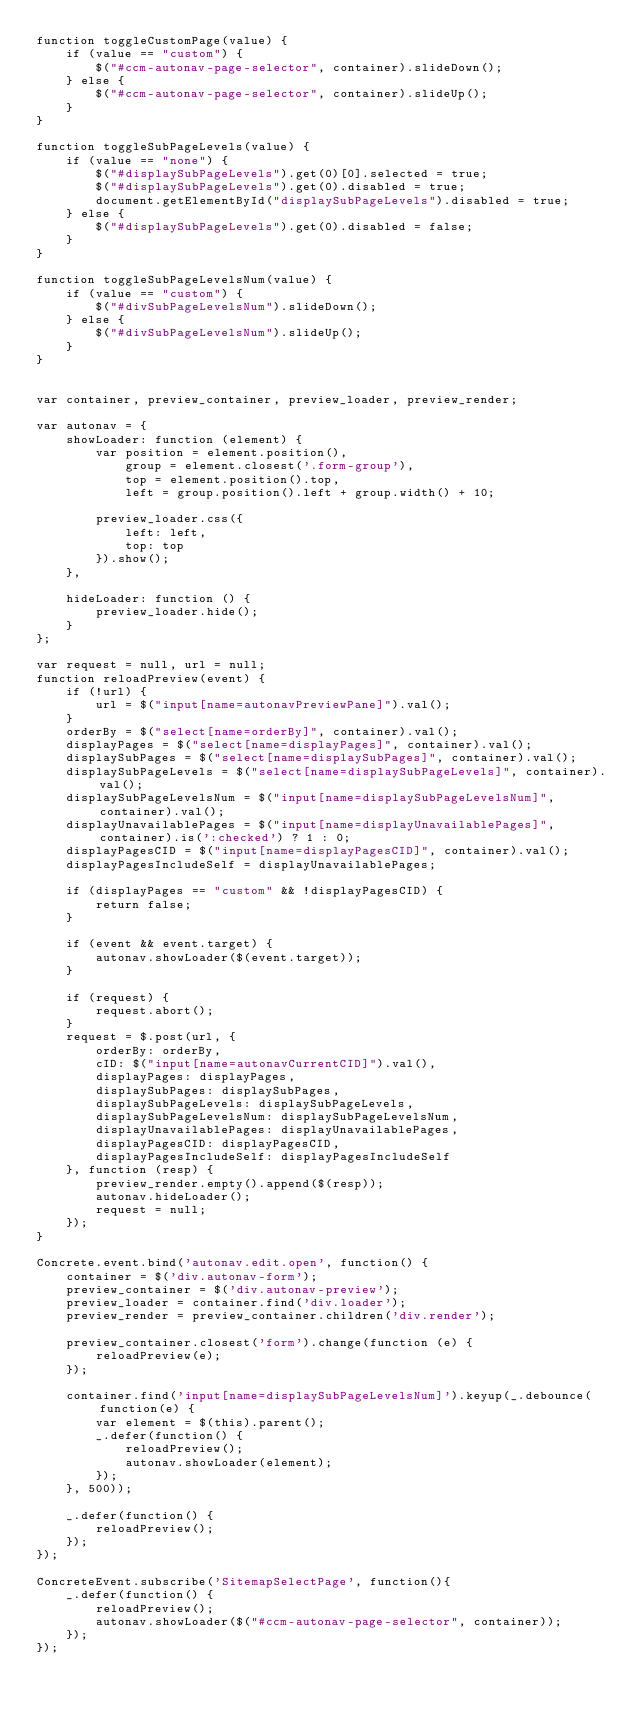<code> <loc_0><loc_0><loc_500><loc_500><_JavaScript_>function toggleCustomPage(value) {
    if (value == "custom") {
        $("#ccm-autonav-page-selector", container).slideDown();
    } else {
        $("#ccm-autonav-page-selector", container).slideUp();
    }
}

function toggleSubPageLevels(value) {
    if (value == "none") {
        $("#displaySubPageLevels").get(0)[0].selected = true;
        $("#displaySubPageLevels").get(0).disabled = true;
        document.getElementById("displaySubPageLevels").disabled = true;
    } else {
        $("#displaySubPageLevels").get(0).disabled = false;
    }
}

function toggleSubPageLevelsNum(value) {
    if (value == "custom") {
        $("#divSubPageLevelsNum").slideDown();
    } else {
        $("#divSubPageLevelsNum").slideUp();
    }
}


var container, preview_container, preview_loader, preview_render;

var autonav = {
    showLoader: function (element) {
        var position = element.position(),
            group = element.closest('.form-group'),
            top = element.position().top,
            left = group.position().left + group.width() + 10;

        preview_loader.css({
            left: left,
            top: top
        }).show();
    },

    hideLoader: function () {
        preview_loader.hide();
    }
};

var request = null, url = null;
function reloadPreview(event) {
    if (!url) {
        url = $("input[name=autonavPreviewPane]").val();
    }
    orderBy = $("select[name=orderBy]", container).val();
    displayPages = $("select[name=displayPages]", container).val();
    displaySubPages = $("select[name=displaySubPages]", container).val();
    displaySubPageLevels = $("select[name=displaySubPageLevels]", container).val();
    displaySubPageLevelsNum = $("input[name=displaySubPageLevelsNum]", container).val();
    displayUnavailablePages = $("input[name=displayUnavailablePages]", container).is(':checked') ? 1 : 0;
    displayPagesCID = $("input[name=displayPagesCID]", container).val();
    displayPagesIncludeSelf = displayUnavailablePages;

    if (displayPages == "custom" && !displayPagesCID) {
        return false;
    }

    if (event && event.target) {
        autonav.showLoader($(event.target));
    }

    if (request) {
        request.abort();
    }
    request = $.post(url, {
        orderBy: orderBy,
        cID: $("input[name=autonavCurrentCID]").val(),
        displayPages: displayPages,
        displaySubPages: displaySubPages,
        displaySubPageLevels: displaySubPageLevels,
        displaySubPageLevelsNum: displaySubPageLevelsNum,
        displayUnavailablePages: displayUnavailablePages,
        displayPagesCID: displayPagesCID,
        displayPagesIncludeSelf: displayPagesIncludeSelf
    }, function (resp) {
        preview_render.empty().append($(resp));
        autonav.hideLoader();
        request = null;
    });
}

Concrete.event.bind('autonav.edit.open', function() {
    container = $('div.autonav-form');
    preview_container = $('div.autonav-preview');
    preview_loader = container.find('div.loader');
    preview_render = preview_container.children('div.render');

    preview_container.closest('form').change(function (e) {
        reloadPreview(e);
    });

    container.find('input[name=displaySubPageLevelsNum]').keyup(_.debounce(function(e) {
        var element = $(this).parent();
        _.defer(function() {
            reloadPreview();
            autonav.showLoader(element);
        });
    }, 500));

    _.defer(function() {
        reloadPreview();
    });
});

ConcreteEvent.subscribe('SitemapSelectPage', function(){
    _.defer(function() {
        reloadPreview();
        autonav.showLoader($("#ccm-autonav-page-selector", container));
    });
});</code> 